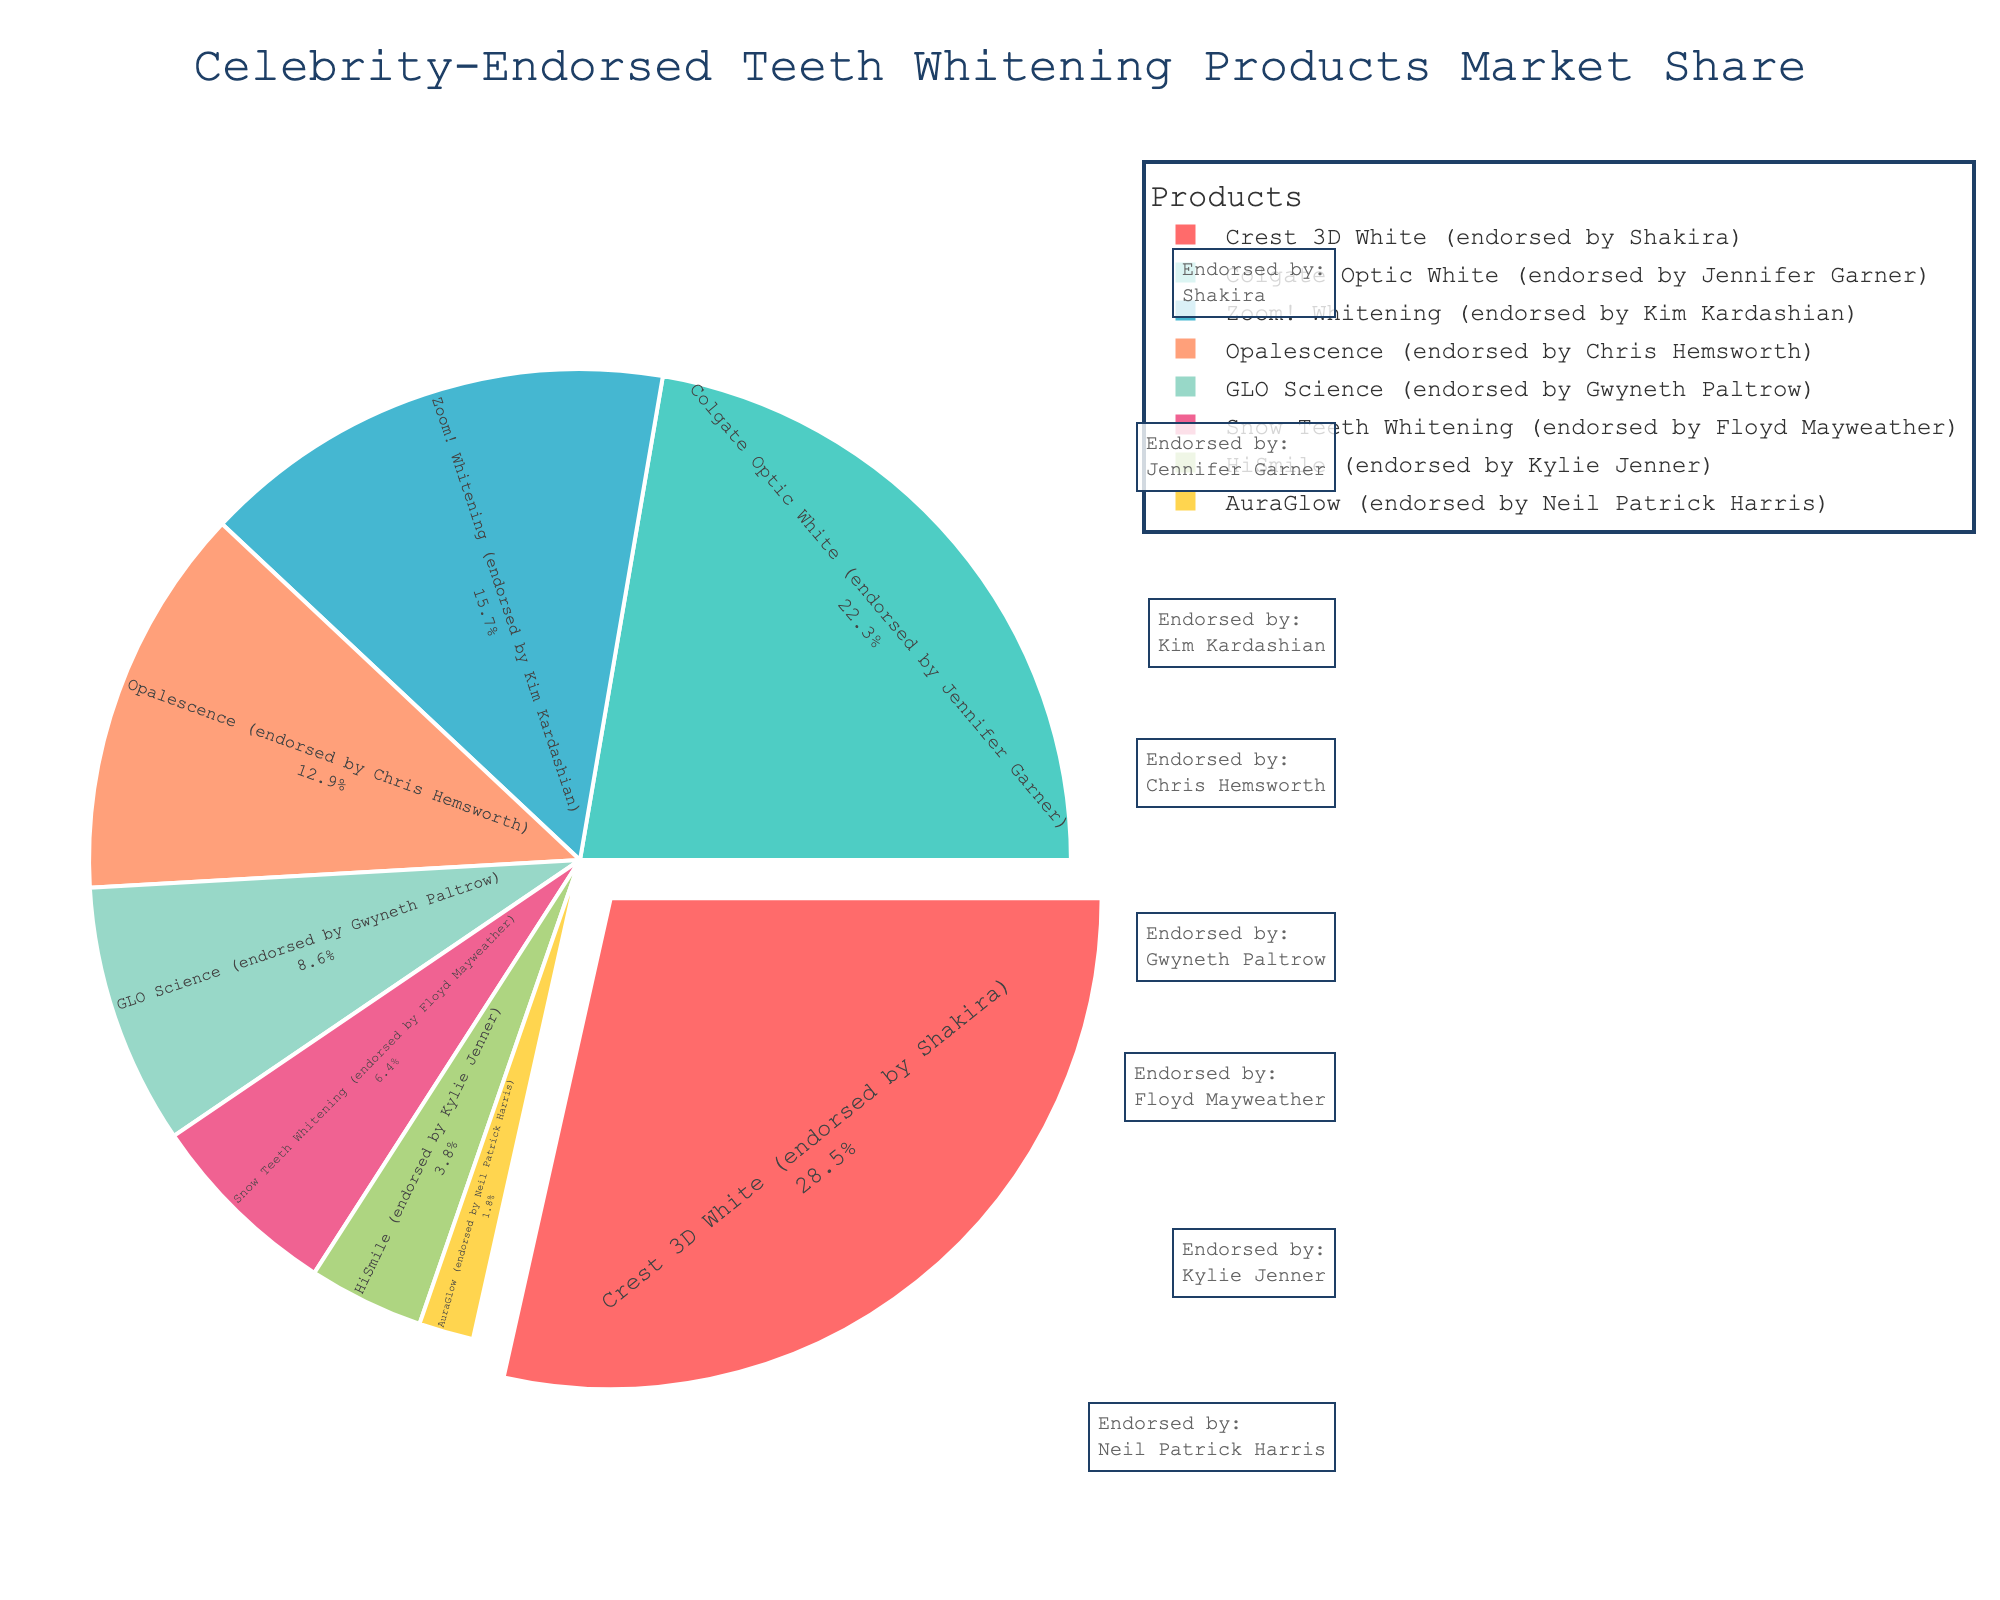What percentage of the market share is held by products endorsed by female celebrities? First, identify the products endorsed by female celebrities: Crest 3D White (Shakira), Colgate Optic White (Jennifer Garner), Zoom! Whitening (Kim Kardashian), GLO Science (Gwyneth Paltrow), HiSmile (Kylie Jenner). Sum their market shares: 28.5 + 22.3 + 15.7 + 8.6 + 3.8 = 78.9%.
Answer: 78.9% Which product has the smallest market share, and who endorses it? Look for the smallest segment in the pie chart, which represents AuraGlow. According to the plot, the endorser is Neil Patrick Harris.
Answer: AuraGlow, Neil Patrick Harris How much larger is the market share of Crest 3D White than Colgate Optic White? Subtract the market share of Colgate Optic White (22.3%) from Crest 3D White (28.5%). The calculation is 28.5 - 22.3 = 6.2.
Answer: 6.2% What is the combined market share of products endorsed by male celebrities? Identify the products endorsed by male celebrities: Opalescence (Chris Hemsworth), Snow Teeth Whitening (Floyd Mayweather), AuraGlow (Neil Patrick Harris). Sum their market shares: 12.9 + 6.4 + 1.8 = 21.1%.
Answer: 21.1% Among the products endorsed by Kim Kardashian and Jennifer Garner, which has a higher market share? Compare the market shares of Zoom! Whitening (Kim Kardashian) and Colgate Optic White (Jennifer Garner). Zoom! Whitening has 15.7%, while Colgate Optic White has 22.3%. Colgate Optic White is higher.
Answer: Colgate Optic White What is the difference in market share between GLO Science and Snow Teeth Whitening? Subtract the market share of Snow Teeth Whitening (6.4%) from GLO Science (8.6%). The calculation is 8.6 - 6.4 = 2.2.
Answer: 2.2% Which product endorsed by a male celebrity has the largest market share? Compare the market shares of Opalescence (12.9%), Snow Teeth Whitening (6.4%), and AuraGlow (1.8%). Opalescence, endorsed by Chris Hemsworth, has the largest market share.
Answer: Opalescence How does the market share of HiSmile compare to AuraGlow? Compare the market shares of HiSmile and AuraGlow. HiSmile has 3.8%, while AuraGlow has 1.8%. HiSmile has a larger market share.
Answer: HiSmile 